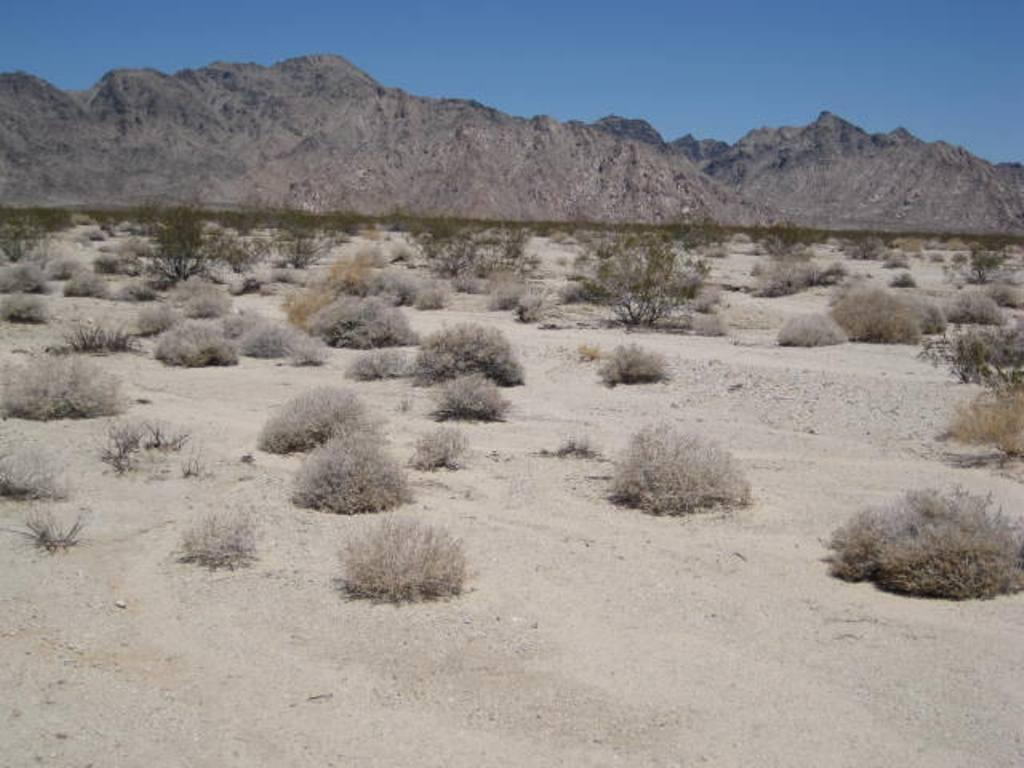What type of living organisms can be seen in the image? Plants can be seen in the image. What geographical feature is located in the middle of the image? There is a hill in the middle of the image. What is visible at the top of the image? The sky is visible at the top of the image. What type of holiday is being celebrated on the floor in the image? There is no holiday or floor present in the image; it features plants and a hill. Is there an island visible in the image? There is no island present in the image; it features plants, a hill, and the sky. 